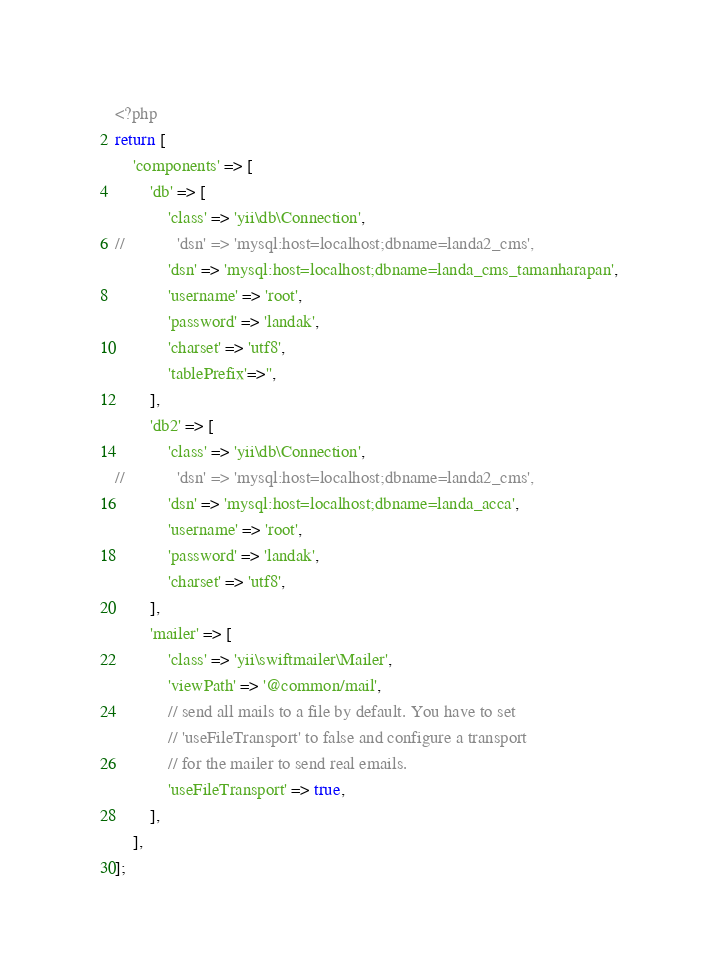Convert code to text. <code><loc_0><loc_0><loc_500><loc_500><_PHP_><?php
return [
    'components' => [
        'db' => [
            'class' => 'yii\db\Connection',
//            'dsn' => 'mysql:host=localhost;dbname=landa2_cms',
            'dsn' => 'mysql:host=localhost;dbname=landa_cms_tamanharapan',
            'username' => 'root',
            'password' => 'landak',
            'charset' => 'utf8',
            'tablePrefix'=>'',
        ],
        'db2' => [
            'class' => 'yii\db\Connection',
//            'dsn' => 'mysql:host=localhost;dbname=landa2_cms',
            'dsn' => 'mysql:host=localhost;dbname=landa_acca',
            'username' => 'root',
            'password' => 'landak',
            'charset' => 'utf8',
        ],
        'mailer' => [
            'class' => 'yii\swiftmailer\Mailer',
            'viewPath' => '@common/mail',
            // send all mails to a file by default. You have to set
            // 'useFileTransport' to false and configure a transport
            // for the mailer to send real emails.
            'useFileTransport' => true,
        ],
    ],
];
</code> 